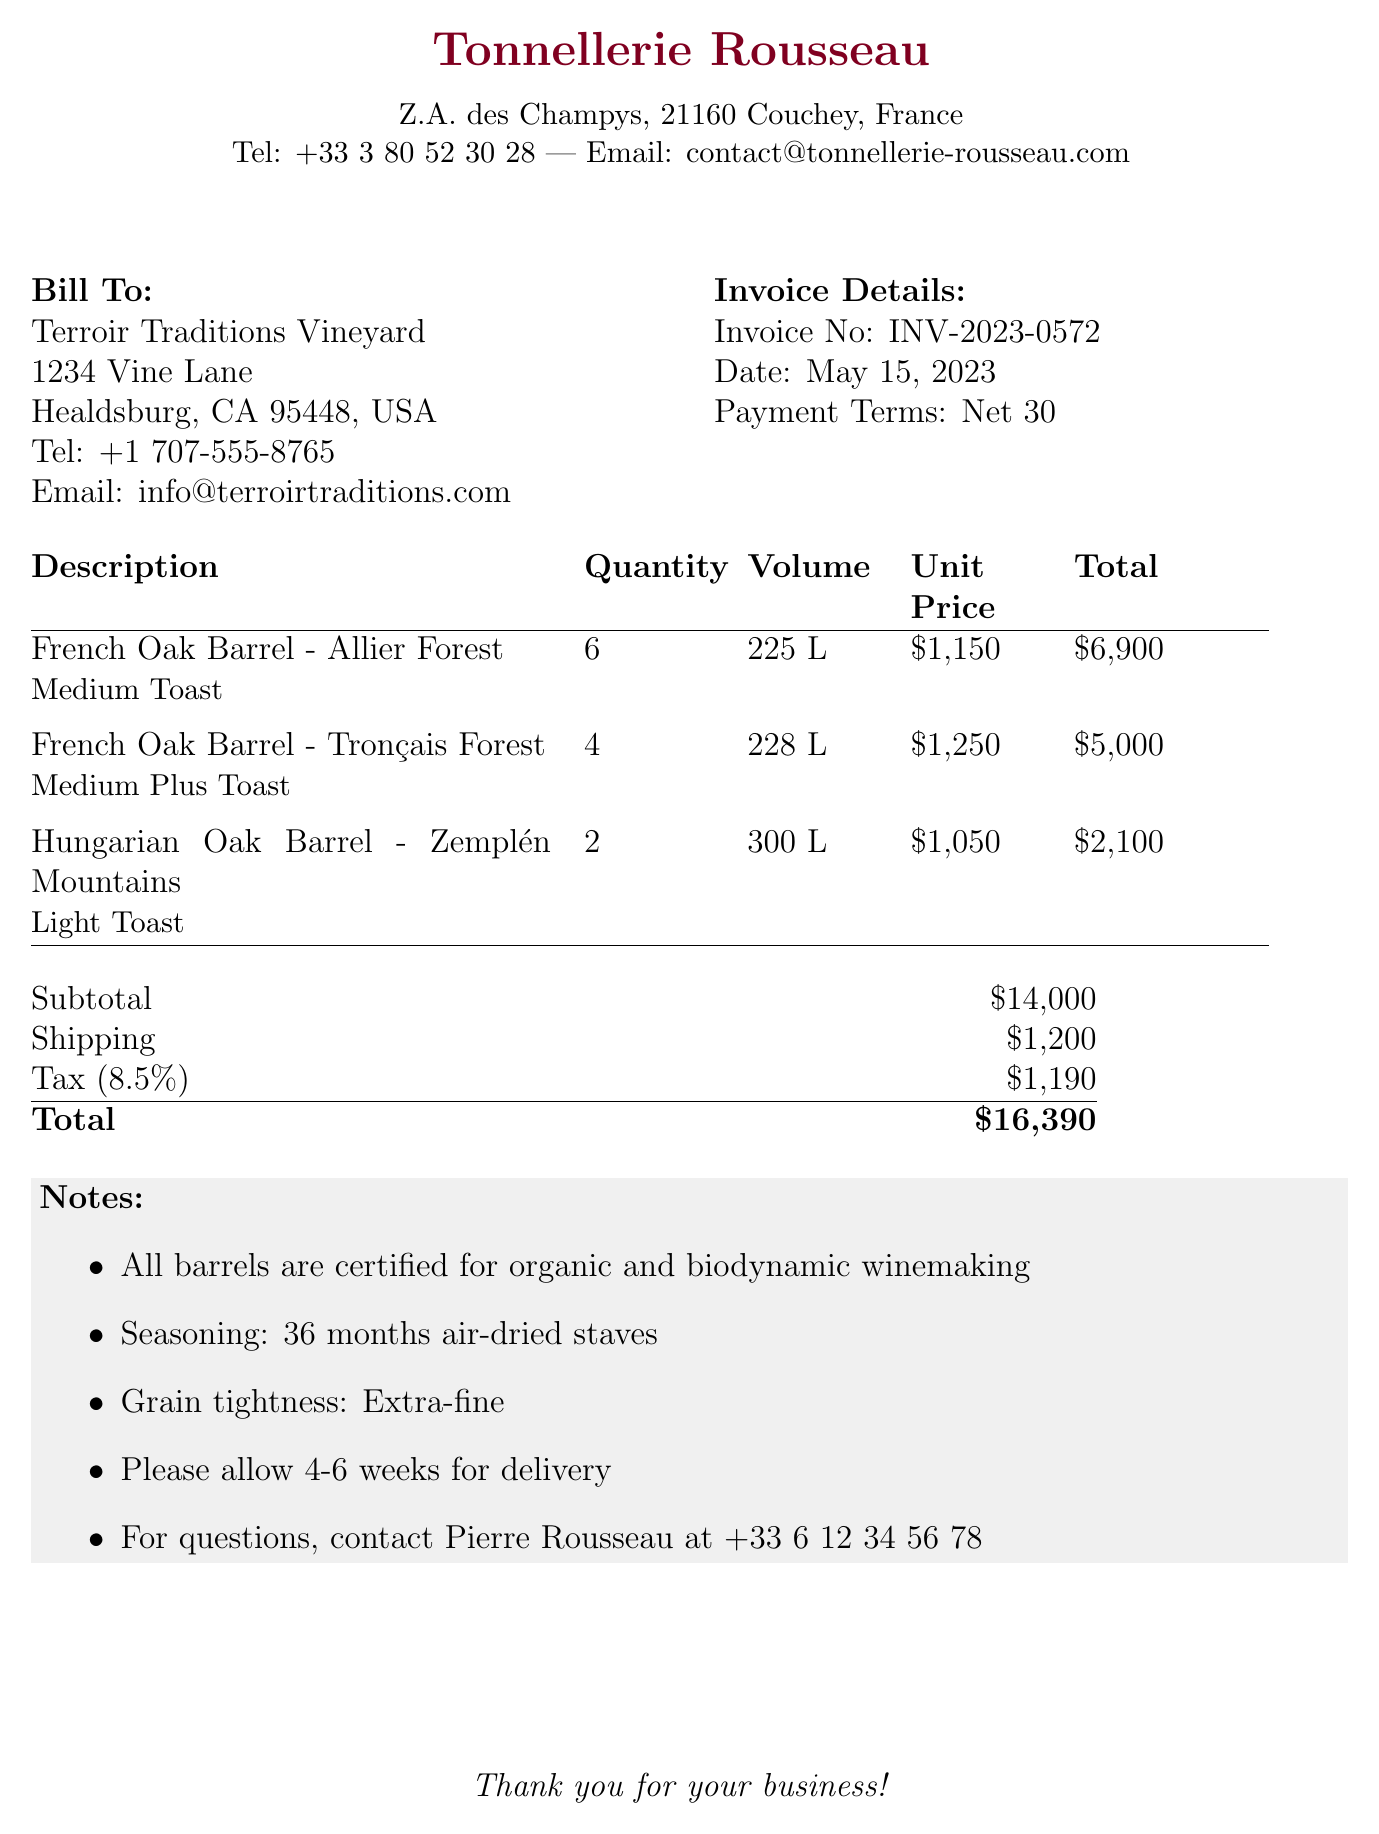What is the invoice number? The invoice number is a unique identifier for tracking the document, listed in the invoice details.
Answer: INV-2023-0572 Who is the supplier? The supplier is the entity selling the barrels, detailed at the top of the invoice.
Answer: Tonnellerie Rousseau What is the total amount due? The total amount is the final payable balance, calculated as the sum of subtotal, shipping, and tax.
Answer: $16,390 What is the volume of the Hungarian Oak Barrel? The volume specifies the capacity of the barrels, which is noted with each item.
Answer: 300 L (79 gallons) What is the toast level for the French Oak Barrel from Allier Forest? The toast level indicates the treatment of the wood before making the barrels and is mentioned beside each item description.
Answer: Medium How many French Oak Barrels are ordered from the Tronçais Forest? The quantity of barrels indicates how many units of a specific type are purchased, seen in the itemized list.
Answer: 4 What payment terms are specified in the invoice? Payment terms indicate how long the customer has to pay the invoice and is mentioned in the invoice details.
Answer: Net 30 How long should delivery take? Delivery time gives an estimate of when the order will arrive, as specified in the notes section.
Answer: 4-6 weeks Are the barrels certified for organic winemaking? This question addresses specific certifications related to agricultural practices mentioned in the notes.
Answer: Yes 